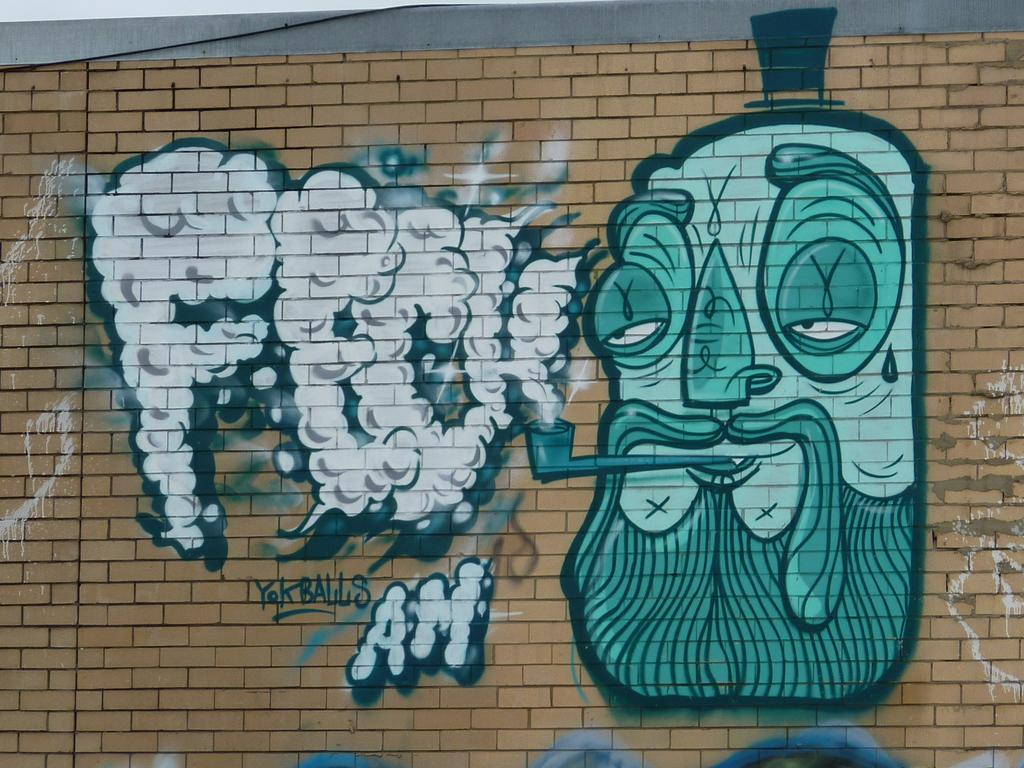What is depicted on the wall in the foreground of the image? There is graffiti painting on the wall in the foreground of the image. What type of feather can be seen incorporated into the graffiti painting in the image? There is no feather present in the graffiti painting in the image. What flavor of zipper is depicted in the graffiti painting in the image? There is no zipper present in the graffiti painting in the image. 